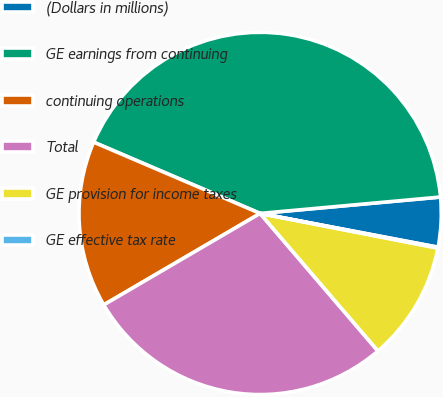Convert chart to OTSL. <chart><loc_0><loc_0><loc_500><loc_500><pie_chart><fcel>(Dollars in millions)<fcel>GE earnings from continuing<fcel>continuing operations<fcel>Total<fcel>GE provision for income taxes<fcel>GE effective tax rate<nl><fcel>4.43%<fcel>42.12%<fcel>14.86%<fcel>27.85%<fcel>10.66%<fcel>0.08%<nl></chart> 